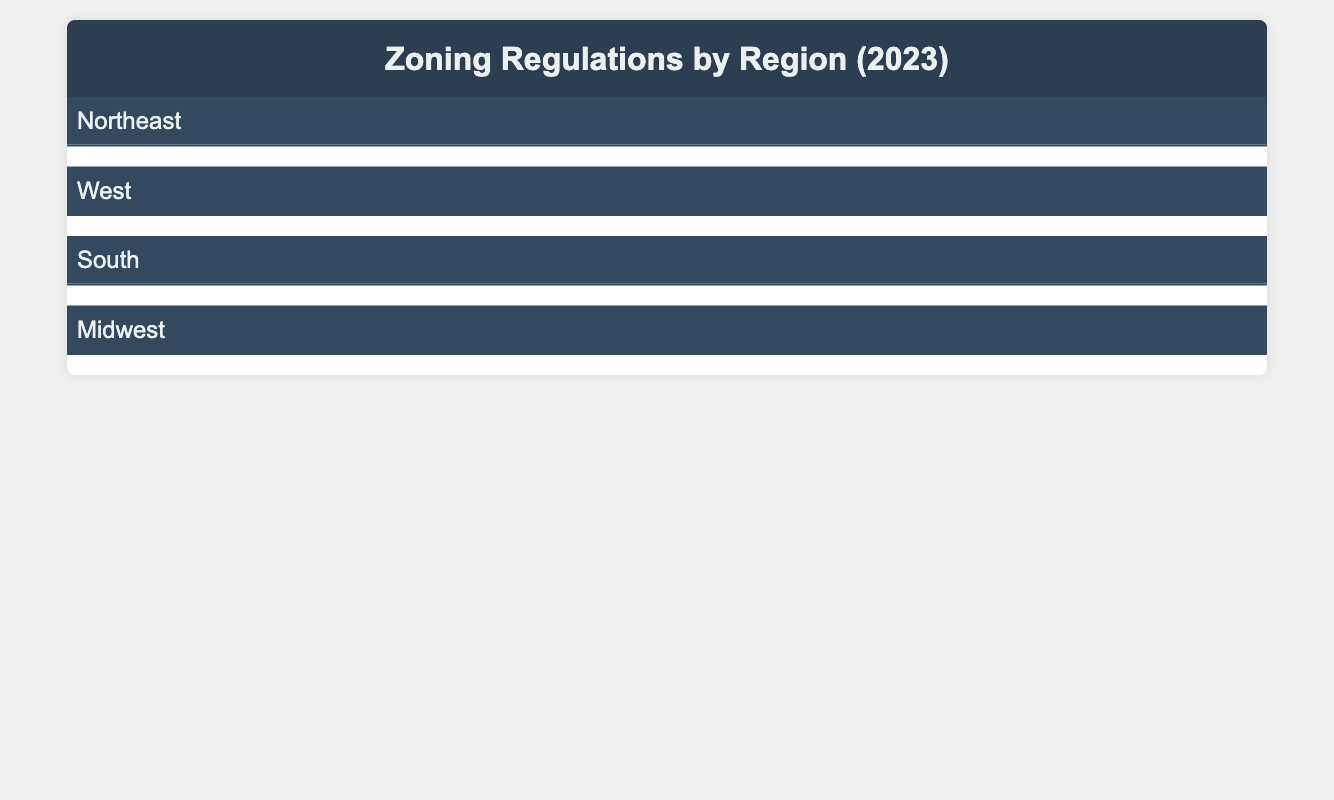What type of zoning is applied in Boston? In the table, under the "Northeast" region and specifically for "Massachusetts" and the city "Boston," it is clearly mentioned that the "Zoning Type" is "Mixed-Use."
Answer: Mixed-Use Does New York City require a zoning permit? The table specifies that for "New York City," the "Zoning Permit" is "Not Required," indicating that it does not require a zoning permit for development activities.
Answer: No What is the maximum height limit for buildings in Chicago? According to the table, for the city of "Chicago" in Illinois under the "Zoning Type" of "Mixed-Use," the "Height Limit" is stated as "120 ft."
Answer: 120 ft How many jurisdictions among Florida and Texas require environmental review? In Texas (Austin), the "Environmental Review" is "Not Required." In Florida (Miami), it is "Required." Thus, only one out of the two jurisdictions requires an environmental review.
Answer: 1 What is the height limit difference between residential zoning in Los Angeles and commercial zoning in Austin? The height limit in "Los Angeles" (Residential zoning) is "35 ft," and in "Austin" (Commercial zoning), it is "90 ft." The difference in height limits is 90 ft - 35 ft = 55 ft.
Answer: 55 ft Is there a parking space requirement in Cleveland, Ohio? The table does not list any parking space requirement for "Cleveland" in Ohio under "Zoning Type" of "Industrial," thus implying that no specific parking space requirement is publicized.
Answer: No What are the required permits for mixed-use zoning in Seattle? In "Seattle" under the "Mixed-Use" zoning, the table indicates that both "Building Permit" and "Zoning Permit" are "Required," while "Environmental Review" is "Not Required." Thus, the required permits are Building and Zoning Permits.
Answer: Building and Zoning Permits How does the zoning type in Miami compare to that in New York City? In Miami, the zoning type is "Residential" while in New York City it is "Commercial." These are two different types of zoning categories which reflect the different purposes they serve in urban planning, but both require building permits.
Answer: Different types: Residential vs. Commercial What percentage of total area must be green space in Chicago? From the table under city "Chicago," it states that "Green Space" is required to be "10% of total area." This indicates a specific green space regulation within its zoning requirements.
Answer: 10% 